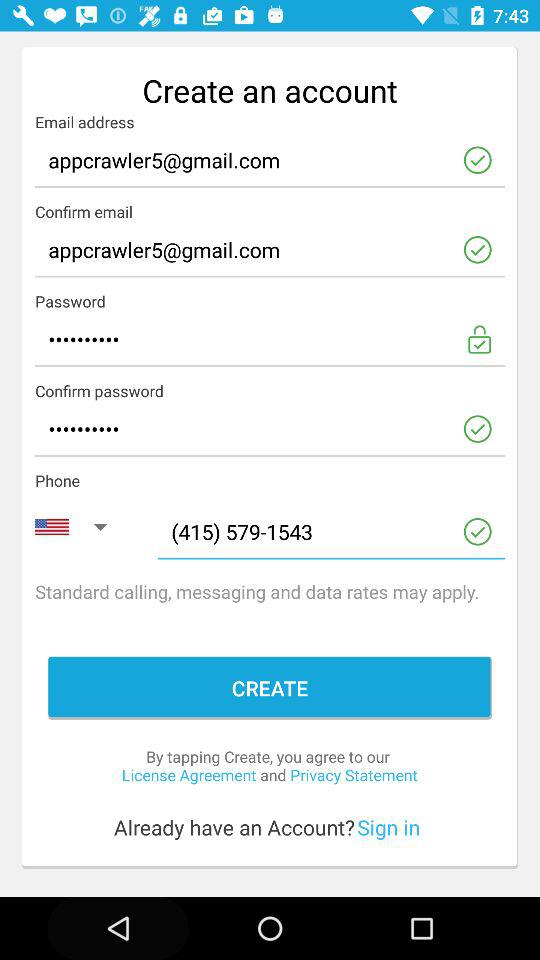What is the mentioned email address? The mentioned email address is appcrawler5@gmail.com. 